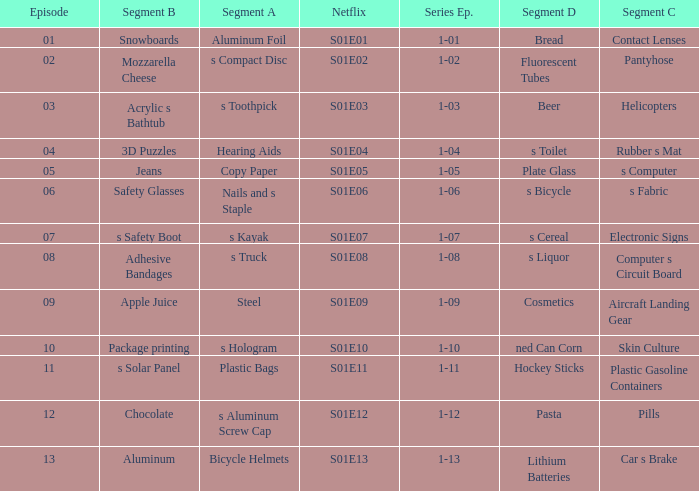What is the segment A name, having a Netflix of s01e12? S aluminum screw cap. 